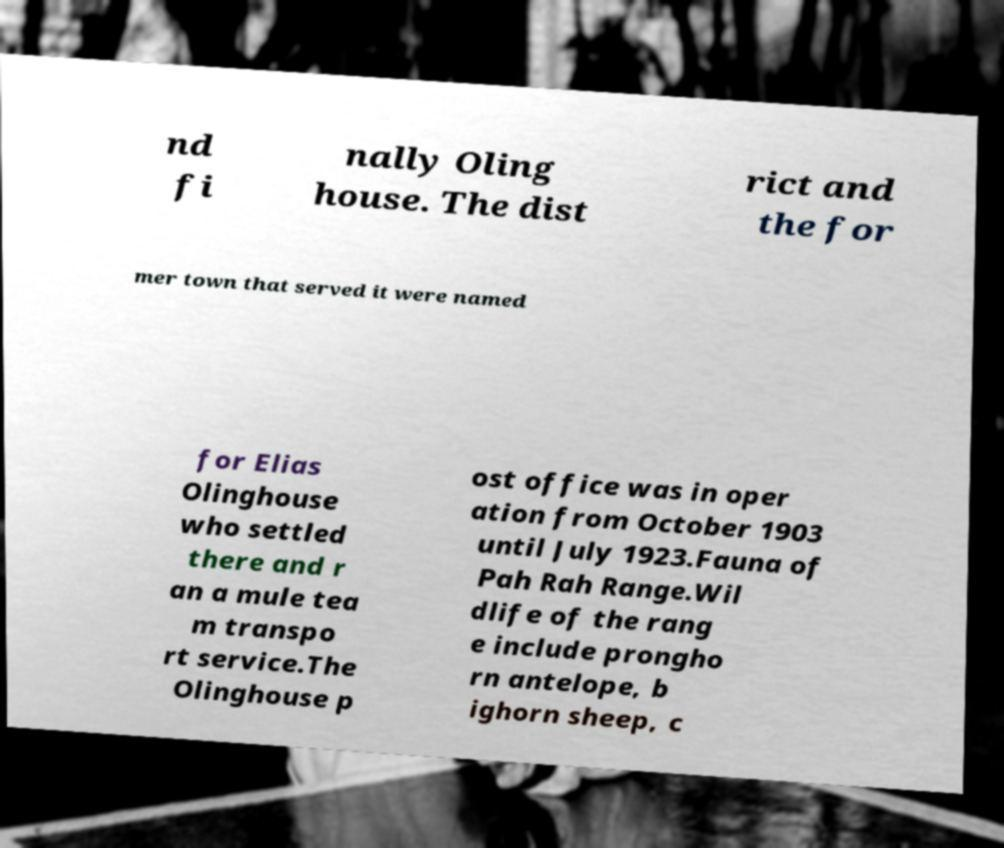Can you accurately transcribe the text from the provided image for me? nd fi nally Oling house. The dist rict and the for mer town that served it were named for Elias Olinghouse who settled there and r an a mule tea m transpo rt service.The Olinghouse p ost office was in oper ation from October 1903 until July 1923.Fauna of Pah Rah Range.Wil dlife of the rang e include prongho rn antelope, b ighorn sheep, c 